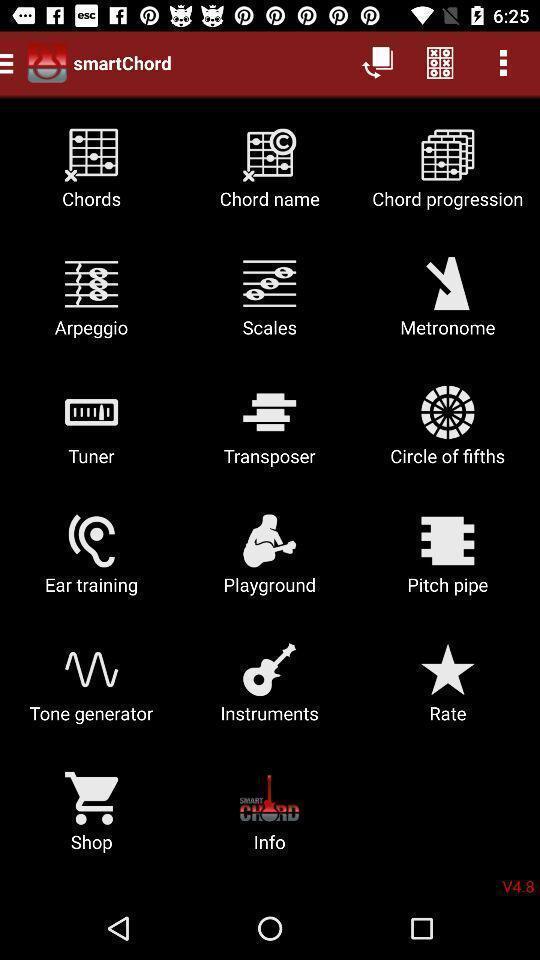Describe the visual elements of this screenshot. Page showing the various options in music app. 